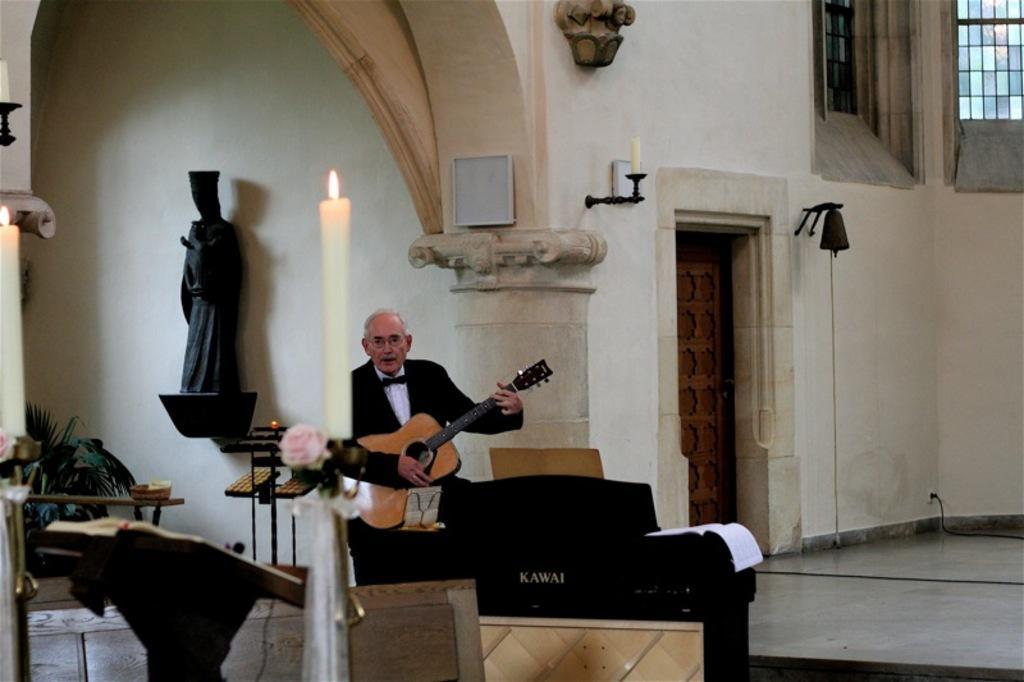Describe this image in one or two sentences. In this picture there is a man playing guitar. There is a black sculpture, candle, plant, book, door. 